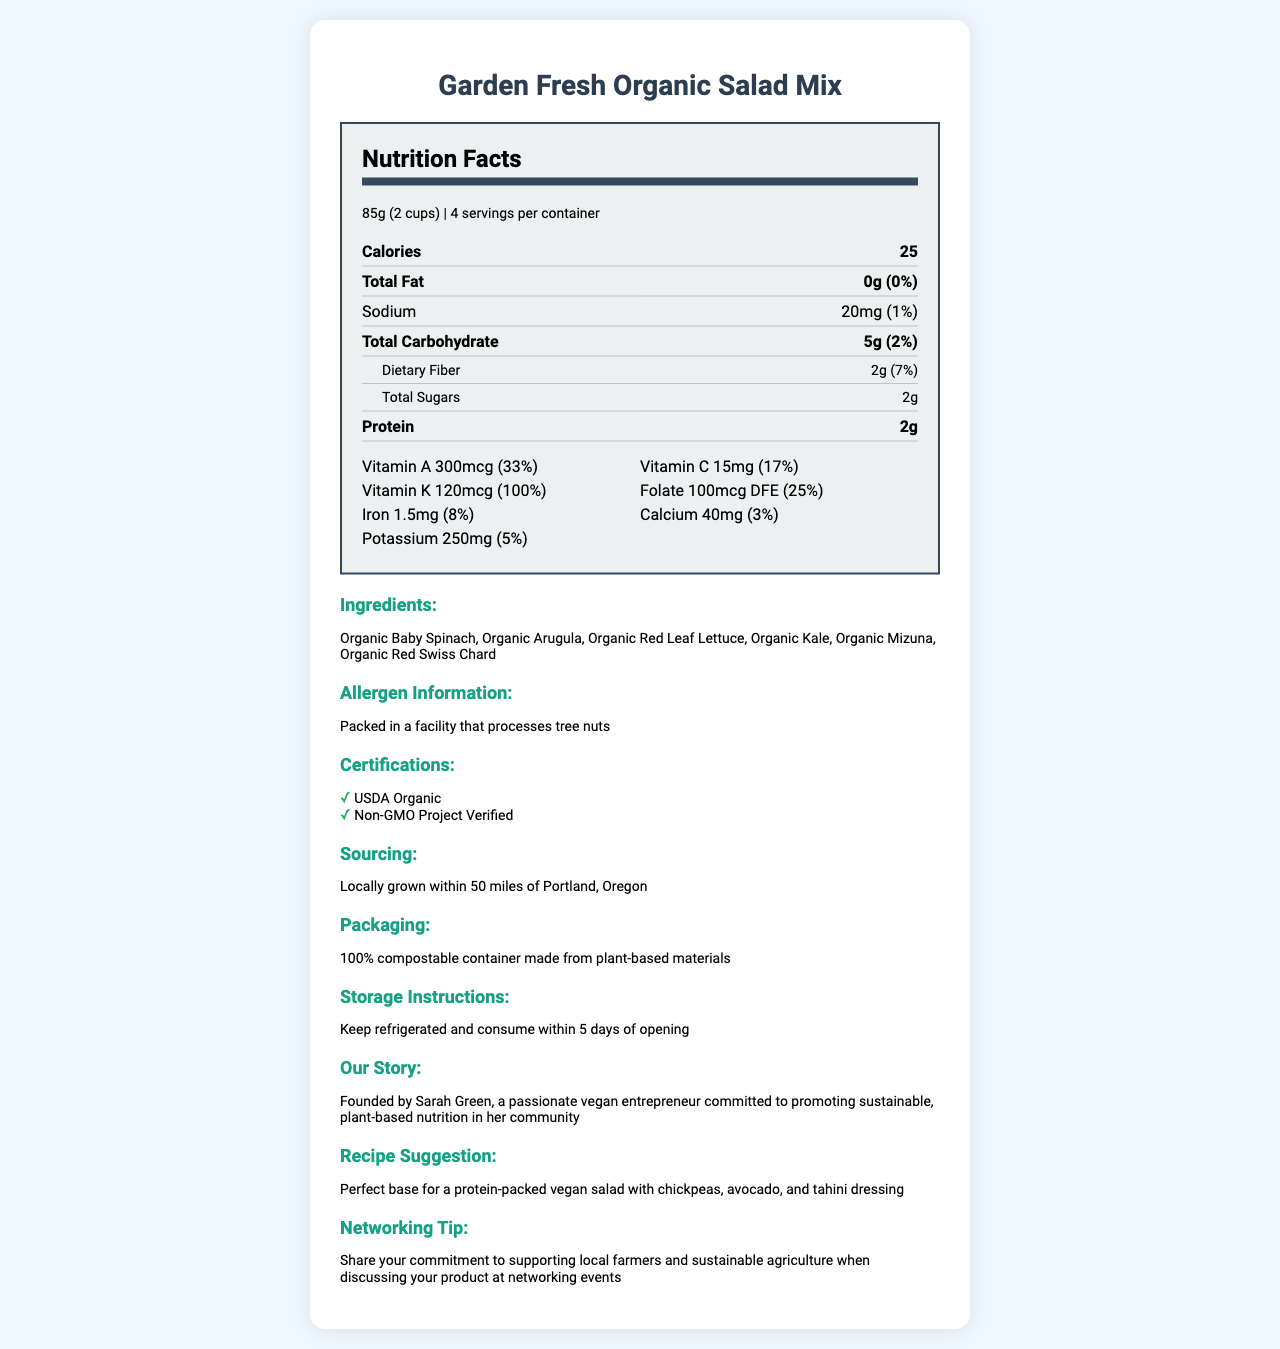what is the serving size of the Garden Fresh Organic Salad Mix? The serving size is clearly listed as 85 grams or 2 cups in the document.
Answer: 85g (2 cups) what is the daily value percentage of vitamin C per serving? The document specifies that the daily value for vitamin C is 17%.
Answer: 17% how many servings are in one container? The document states that there are 4 servings per container.
Answer: 4 what is the total carbohydrate content per serving? The nutrient section indicates that each serving contains 5 grams of total carbohydrates.
Answer: 5g which vitamin has the highest daily value percentage in this salad mix? According to the document, Vitamin K has a daily value percentage of 100%, which is the highest compared to other listed vitamins.
Answer: Vitamin K what is the sodium content in one serving? The sodium content per serving is listed as 20 mg in the document.
Answer: 20mg which ingredients are included in the Garden Fresh Organic Salad Mix? A. Organic Baby Spinach, Organic Arugula B. Organic Kale, Organic Red Swiss Chard C. Both A and B The ingredients list includes Organic Baby Spinach, Organic Arugula, Organic Red Leaf Lettuce, Organic Kale, Organic Mizuna, and Organic Red Swiss Chard.
Answer: C what is the product certification mentioned in the document? A. USDA Organic B. Non-GMO Project Verified C. Both A and B The document lists both USDA Organic and Non-GMO Project Verified as certifications.
Answer: C is the salad mix packed in a facility that processes tree nuts? The allergen information clearly states that the salad mix is packed in a facility that processes tree nuts.
Answer: Yes does the packaging of the salad mix use compostable materials? The packaging section mentions that it is a 100% compostable container made from plant-based materials.
Answer: Yes how much iron is in one serving of the Garden Fresh Organic Salad Mix? The iron content per serving is listed as 1.5 mg in the document.
Answer: 1.5mg describe the main idea of the document. The document serves as a comprehensive guide to the nutritional content, sourcing, packaging, and additional information for the Garden Fresh Organic Salad Mix, emphasizing its organic and sustainable attributes.
Answer: The document provides detailed nutrition facts for the Garden Fresh Organic Salad Mix, including serving size, calorie content, and micronutrient values. It also lists ingredients, allergen information, certifications, sourcing details, packaging, storage instructions, the business story, a recipe suggestion, and a networking tip. what are the storage instructions for the salad mix? The storage instructions clearly state to keep the product refrigerated and consume it within 5 days of opening.
Answer: Keep refrigerated and consume within 5 days of opening who founded the company producing this salad mix? The business story section reveals that Sarah Green is the founder of the company.
Answer: Sarah Green what is the revenue generated from this product? The document does not provide any financial information such as revenue generated from this product.
Answer: Cannot be determined 